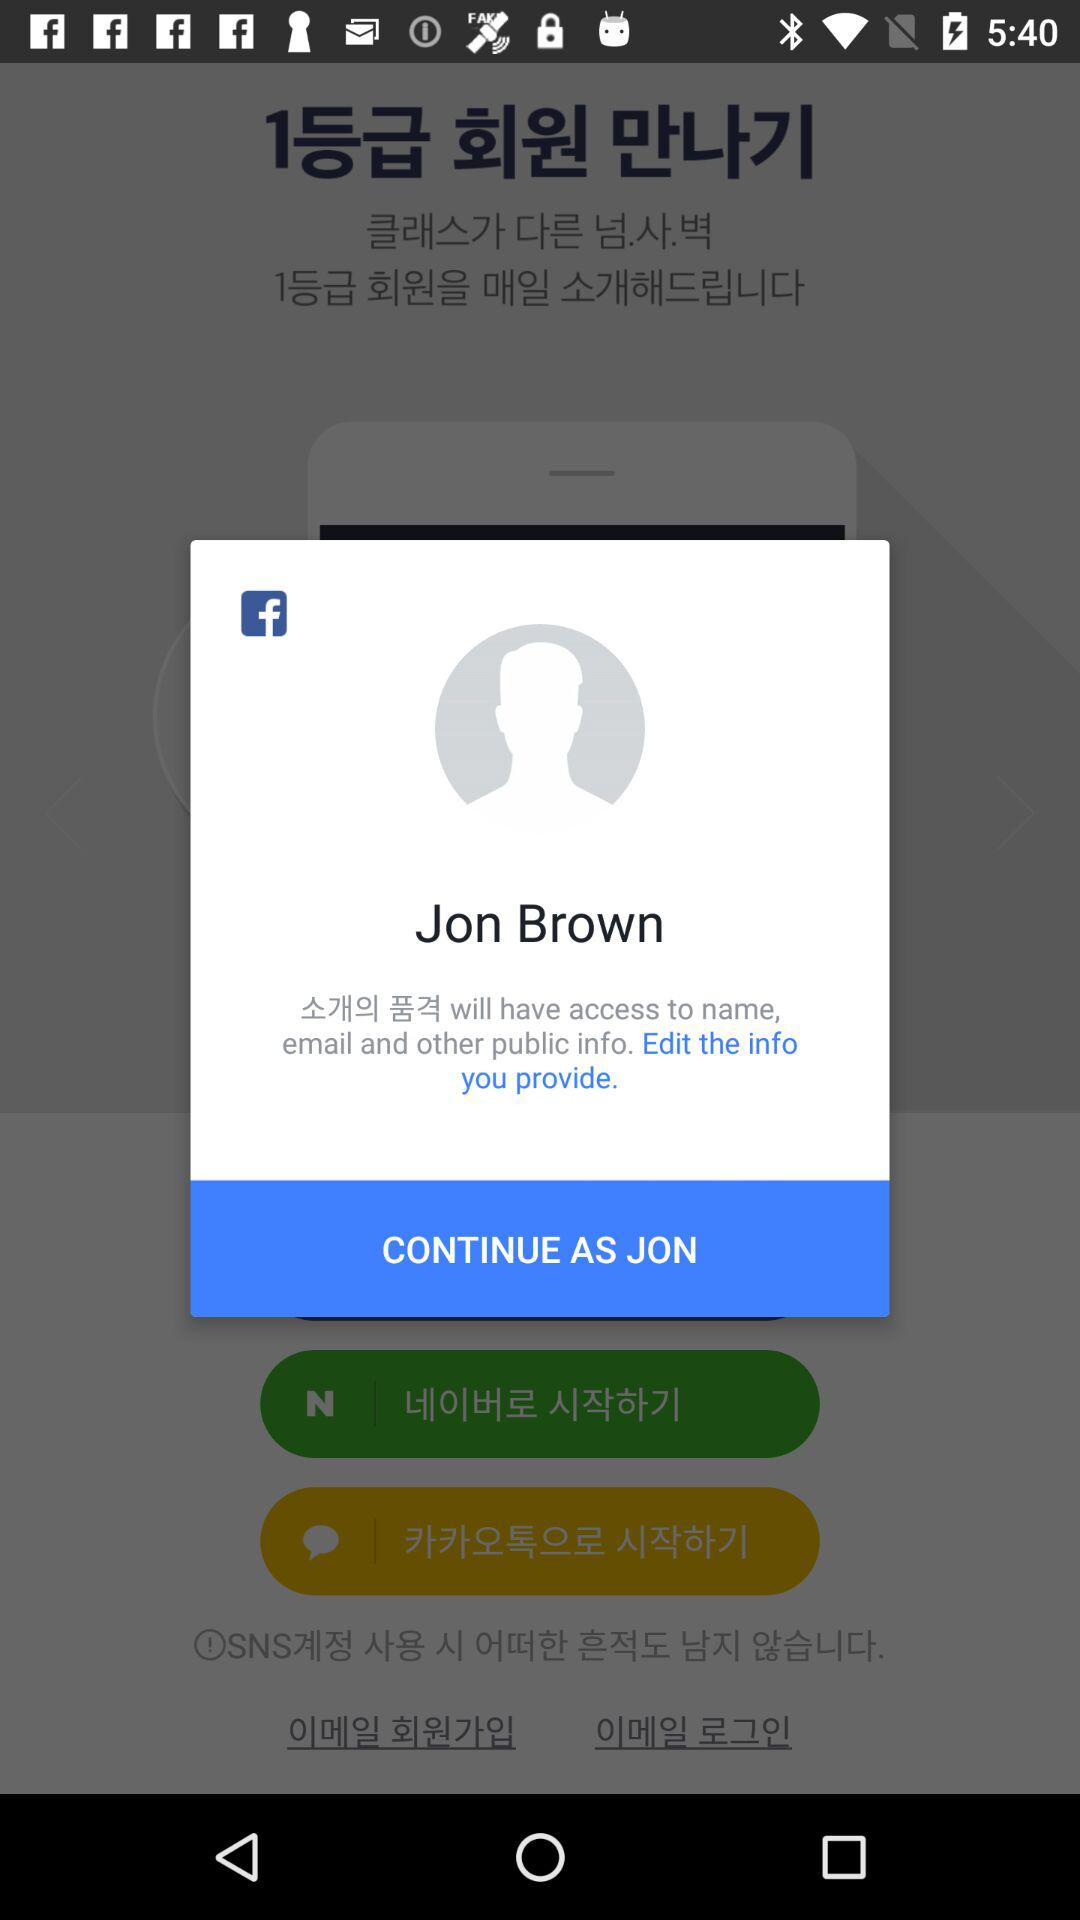What is the name of the user? The name of the user is Jon Brown. 